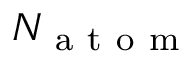<formula> <loc_0><loc_0><loc_500><loc_500>N _ { a t o m }</formula> 